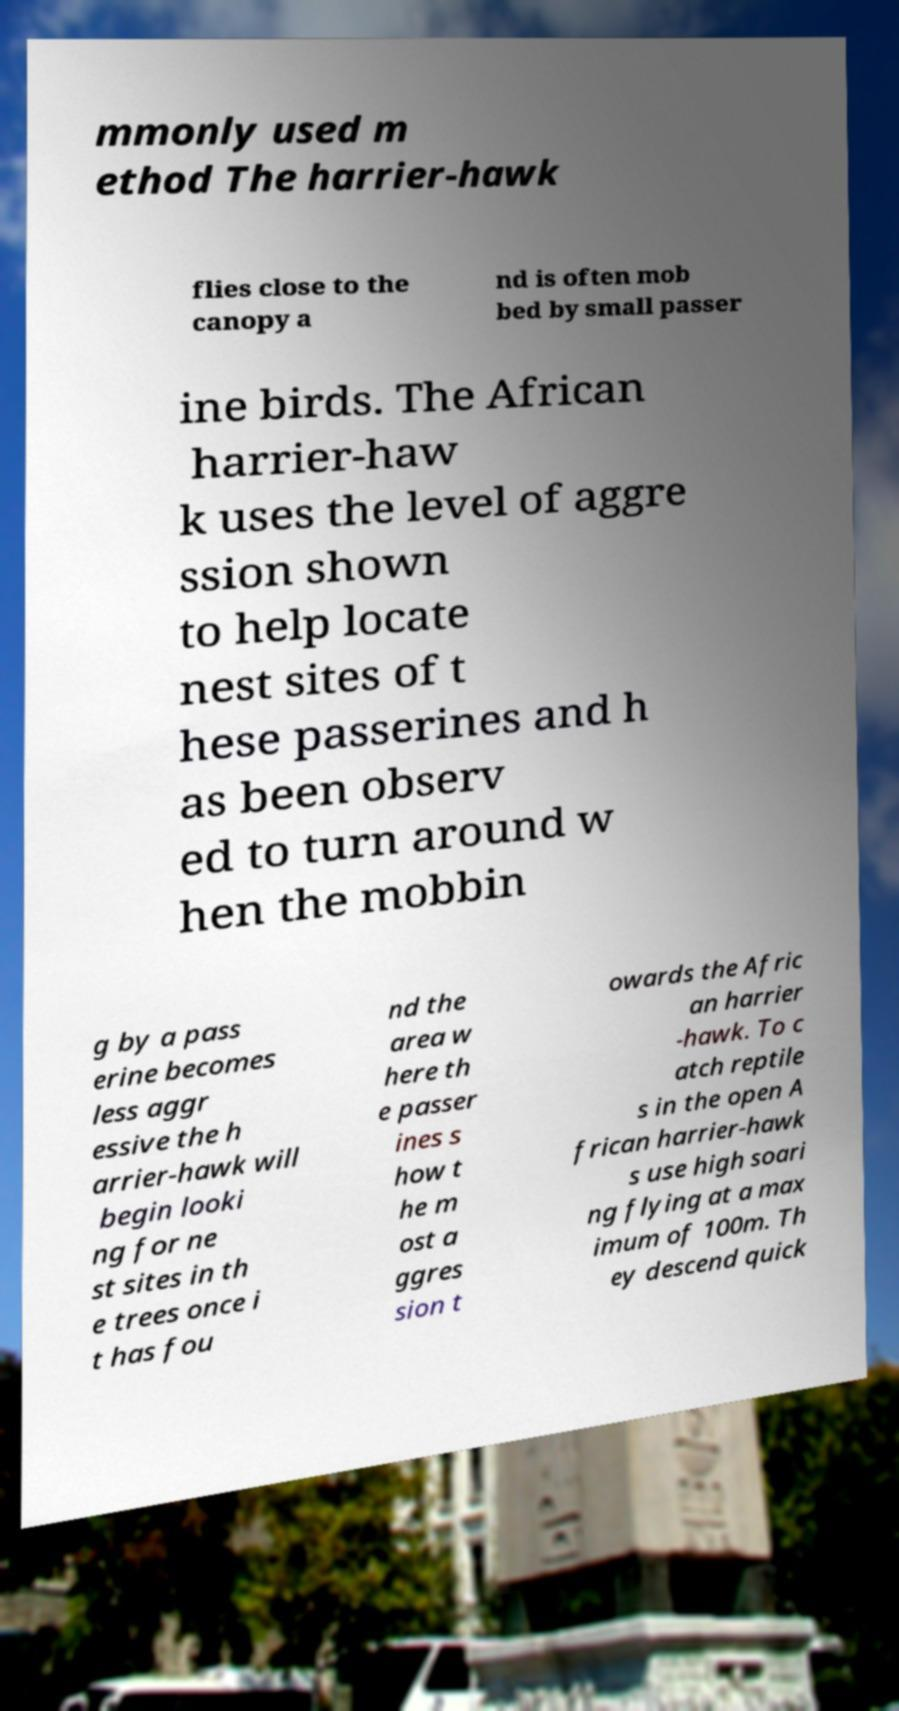Could you assist in decoding the text presented in this image and type it out clearly? mmonly used m ethod The harrier-hawk flies close to the canopy a nd is often mob bed by small passer ine birds. The African harrier-haw k uses the level of aggre ssion shown to help locate nest sites of t hese passerines and h as been observ ed to turn around w hen the mobbin g by a pass erine becomes less aggr essive the h arrier-hawk will begin looki ng for ne st sites in th e trees once i t has fou nd the area w here th e passer ines s how t he m ost a ggres sion t owards the Afric an harrier -hawk. To c atch reptile s in the open A frican harrier-hawk s use high soari ng flying at a max imum of 100m. Th ey descend quick 